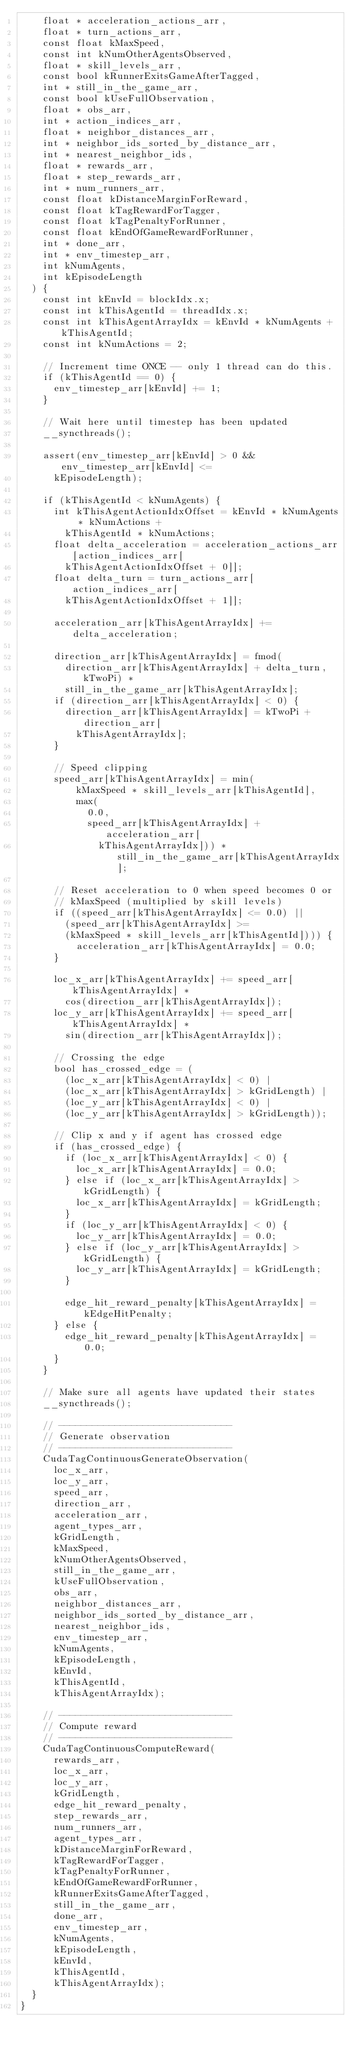<code> <loc_0><loc_0><loc_500><loc_500><_Cuda_>    float * acceleration_actions_arr,
    float * turn_actions_arr,
    const float kMaxSpeed,
    const int kNumOtherAgentsObserved,
    float * skill_levels_arr,
    const bool kRunnerExitsGameAfterTagged,
    int * still_in_the_game_arr,
    const bool kUseFullObservation,
    float * obs_arr,
    int * action_indices_arr,
    float * neighbor_distances_arr,
    int * neighbor_ids_sorted_by_distance_arr,
    int * nearest_neighbor_ids,
    float * rewards_arr,
    float * step_rewards_arr,
    int * num_runners_arr,
    const float kDistanceMarginForReward,
    const float kTagRewardForTagger,
    const float kTagPenaltyForRunner,
    const float kEndOfGameRewardForRunner,
    int * done_arr,
    int * env_timestep_arr,
    int kNumAgents,
    int kEpisodeLength
  ) {
    const int kEnvId = blockIdx.x;
    const int kThisAgentId = threadIdx.x;
    const int kThisAgentArrayIdx = kEnvId * kNumAgents + kThisAgentId;
    const int kNumActions = 2;

    // Increment time ONCE -- only 1 thread can do this.
    if (kThisAgentId == 0) {
      env_timestep_arr[kEnvId] += 1;
    }

    // Wait here until timestep has been updated
    __syncthreads();

    assert(env_timestep_arr[kEnvId] > 0 && env_timestep_arr[kEnvId] <=
      kEpisodeLength);

    if (kThisAgentId < kNumAgents) {
      int kThisAgentActionIdxOffset = kEnvId * kNumAgents * kNumActions +
        kThisAgentId * kNumActions;
      float delta_acceleration = acceleration_actions_arr[action_indices_arr[
        kThisAgentActionIdxOffset + 0]];
      float delta_turn = turn_actions_arr[action_indices_arr[
        kThisAgentActionIdxOffset + 1]];

      acceleration_arr[kThisAgentArrayIdx] += delta_acceleration;

      direction_arr[kThisAgentArrayIdx] = fmod(
        direction_arr[kThisAgentArrayIdx] + delta_turn, kTwoPi) *
        still_in_the_game_arr[kThisAgentArrayIdx];
      if (direction_arr[kThisAgentArrayIdx] < 0) {
        direction_arr[kThisAgentArrayIdx] = kTwoPi + direction_arr[
          kThisAgentArrayIdx];
      }

      // Speed clipping
      speed_arr[kThisAgentArrayIdx] = min(
          kMaxSpeed * skill_levels_arr[kThisAgentId],
          max(
            0.0,
            speed_arr[kThisAgentArrayIdx] + acceleration_arr[
              kThisAgentArrayIdx])) * still_in_the_game_arr[kThisAgentArrayIdx];

      // Reset acceleration to 0 when speed becomes 0 or
      // kMaxSpeed (multiplied by skill levels)
      if ((speed_arr[kThisAgentArrayIdx] <= 0.0) ||
        (speed_arr[kThisAgentArrayIdx] >=
        (kMaxSpeed * skill_levels_arr[kThisAgentId]))) {
          acceleration_arr[kThisAgentArrayIdx] = 0.0;
      }

      loc_x_arr[kThisAgentArrayIdx] += speed_arr[kThisAgentArrayIdx] *
        cos(direction_arr[kThisAgentArrayIdx]);
      loc_y_arr[kThisAgentArrayIdx] += speed_arr[kThisAgentArrayIdx] *
        sin(direction_arr[kThisAgentArrayIdx]);

      // Crossing the edge
      bool has_crossed_edge = (
        (loc_x_arr[kThisAgentArrayIdx] < 0) |
        (loc_x_arr[kThisAgentArrayIdx] > kGridLength) |
        (loc_y_arr[kThisAgentArrayIdx] < 0) |
        (loc_y_arr[kThisAgentArrayIdx] > kGridLength));

      // Clip x and y if agent has crossed edge
      if (has_crossed_edge) {
        if (loc_x_arr[kThisAgentArrayIdx] < 0) {
          loc_x_arr[kThisAgentArrayIdx] = 0.0;
        } else if (loc_x_arr[kThisAgentArrayIdx] > kGridLength) {
          loc_x_arr[kThisAgentArrayIdx] = kGridLength;
        }
        if (loc_y_arr[kThisAgentArrayIdx] < 0) {
          loc_y_arr[kThisAgentArrayIdx] = 0.0;
        } else if (loc_y_arr[kThisAgentArrayIdx] > kGridLength) {
          loc_y_arr[kThisAgentArrayIdx] = kGridLength;
        }

        edge_hit_reward_penalty[kThisAgentArrayIdx] = kEdgeHitPenalty;
      } else {
        edge_hit_reward_penalty[kThisAgentArrayIdx] = 0.0;
      }
    }

    // Make sure all agents have updated their states
    __syncthreads();

    // -------------------------------
    // Generate observation
    // -------------------------------
    CudaTagContinuousGenerateObservation(
      loc_x_arr,
      loc_y_arr,
      speed_arr,
      direction_arr,
      acceleration_arr,
      agent_types_arr,
      kGridLength,
      kMaxSpeed,
      kNumOtherAgentsObserved,
      still_in_the_game_arr,
      kUseFullObservation,
      obs_arr,
      neighbor_distances_arr,
      neighbor_ids_sorted_by_distance_arr,
      nearest_neighbor_ids,
      env_timestep_arr,
      kNumAgents,
      kEpisodeLength,
      kEnvId,
      kThisAgentId,
      kThisAgentArrayIdx);

    // -------------------------------
    // Compute reward
    // -------------------------------
    CudaTagContinuousComputeReward(
      rewards_arr,
      loc_x_arr,
      loc_y_arr,
      kGridLength,
      edge_hit_reward_penalty,
      step_rewards_arr,
      num_runners_arr,
      agent_types_arr,
      kDistanceMarginForReward,
      kTagRewardForTagger,
      kTagPenaltyForRunner,
      kEndOfGameRewardForRunner,
      kRunnerExitsGameAfterTagged,
      still_in_the_game_arr,
      done_arr,
      env_timestep_arr,
      kNumAgents,
      kEpisodeLength,
      kEnvId,
      kThisAgentId,
      kThisAgentArrayIdx);
  }
}
</code> 